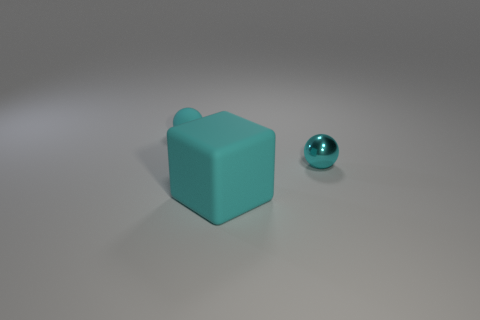Is the color of the matte thing that is to the left of the cyan cube the same as the tiny metal sphere?
Make the answer very short. Yes. What number of objects are either big matte things or rubber things in front of the matte sphere?
Ensure brevity in your answer.  1. What is the material of the object that is both behind the cyan matte cube and to the right of the small cyan matte object?
Keep it short and to the point. Metal. There is a cyan sphere that is behind the shiny thing; what is its material?
Provide a short and direct response. Rubber. What color is the tiny sphere that is the same material as the big cyan block?
Your answer should be very brief. Cyan. Does the small shiny thing have the same shape as the cyan object behind the cyan metal thing?
Ensure brevity in your answer.  Yes. Are there any large cyan objects on the left side of the cyan matte ball?
Provide a short and direct response. No. There is another ball that is the same color as the tiny matte sphere; what is its material?
Your answer should be very brief. Metal. There is a cube; is its size the same as the cyan metal ball right of the tiny matte sphere?
Provide a short and direct response. No. Is there another tiny sphere that has the same color as the matte ball?
Offer a terse response. Yes. 